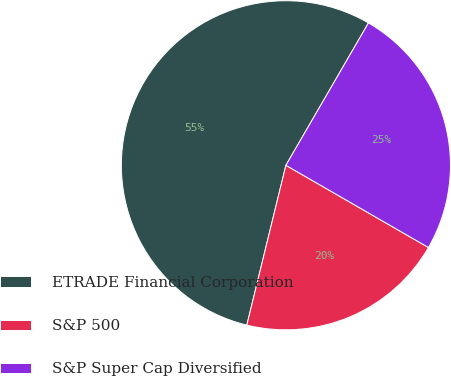<chart> <loc_0><loc_0><loc_500><loc_500><pie_chart><fcel>ETRADE Financial Corporation<fcel>S&P 500<fcel>S&P Super Cap Diversified<nl><fcel>54.54%<fcel>20.49%<fcel>24.96%<nl></chart> 